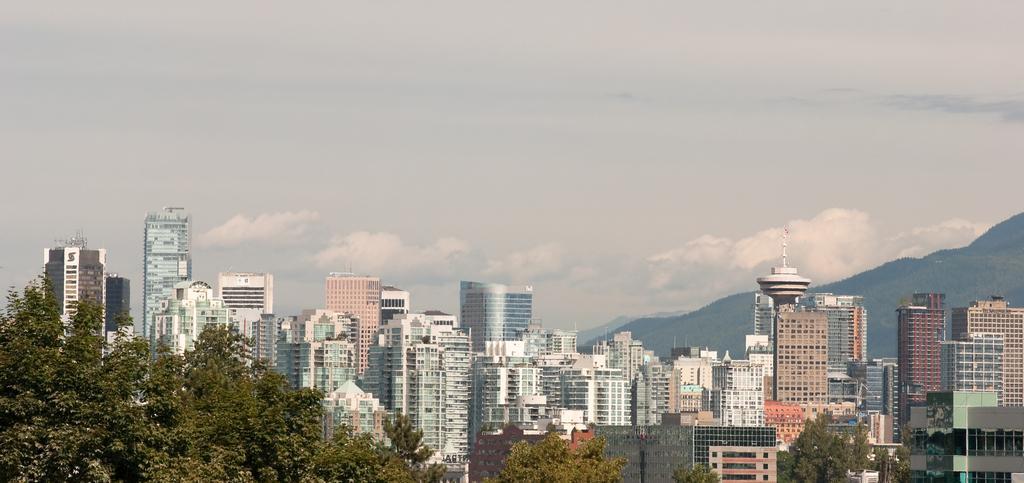Describe this image in one or two sentences. In this image, we can see there are buildings, trees and mountains on the ground. And there are clouds in the sky. 